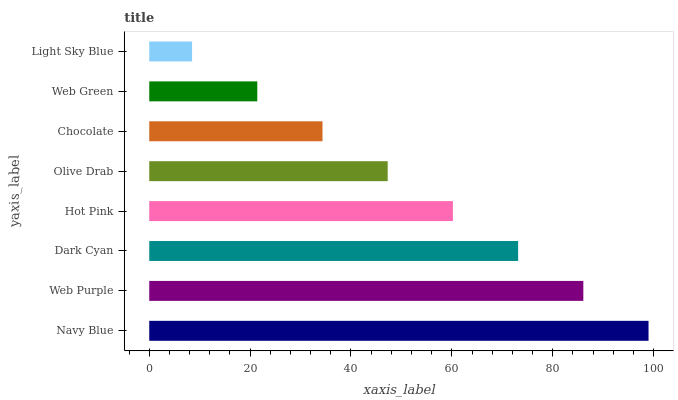Is Light Sky Blue the minimum?
Answer yes or no. Yes. Is Navy Blue the maximum?
Answer yes or no. Yes. Is Web Purple the minimum?
Answer yes or no. No. Is Web Purple the maximum?
Answer yes or no. No. Is Navy Blue greater than Web Purple?
Answer yes or no. Yes. Is Web Purple less than Navy Blue?
Answer yes or no. Yes. Is Web Purple greater than Navy Blue?
Answer yes or no. No. Is Navy Blue less than Web Purple?
Answer yes or no. No. Is Hot Pink the high median?
Answer yes or no. Yes. Is Olive Drab the low median?
Answer yes or no. Yes. Is Web Purple the high median?
Answer yes or no. No. Is Web Purple the low median?
Answer yes or no. No. 